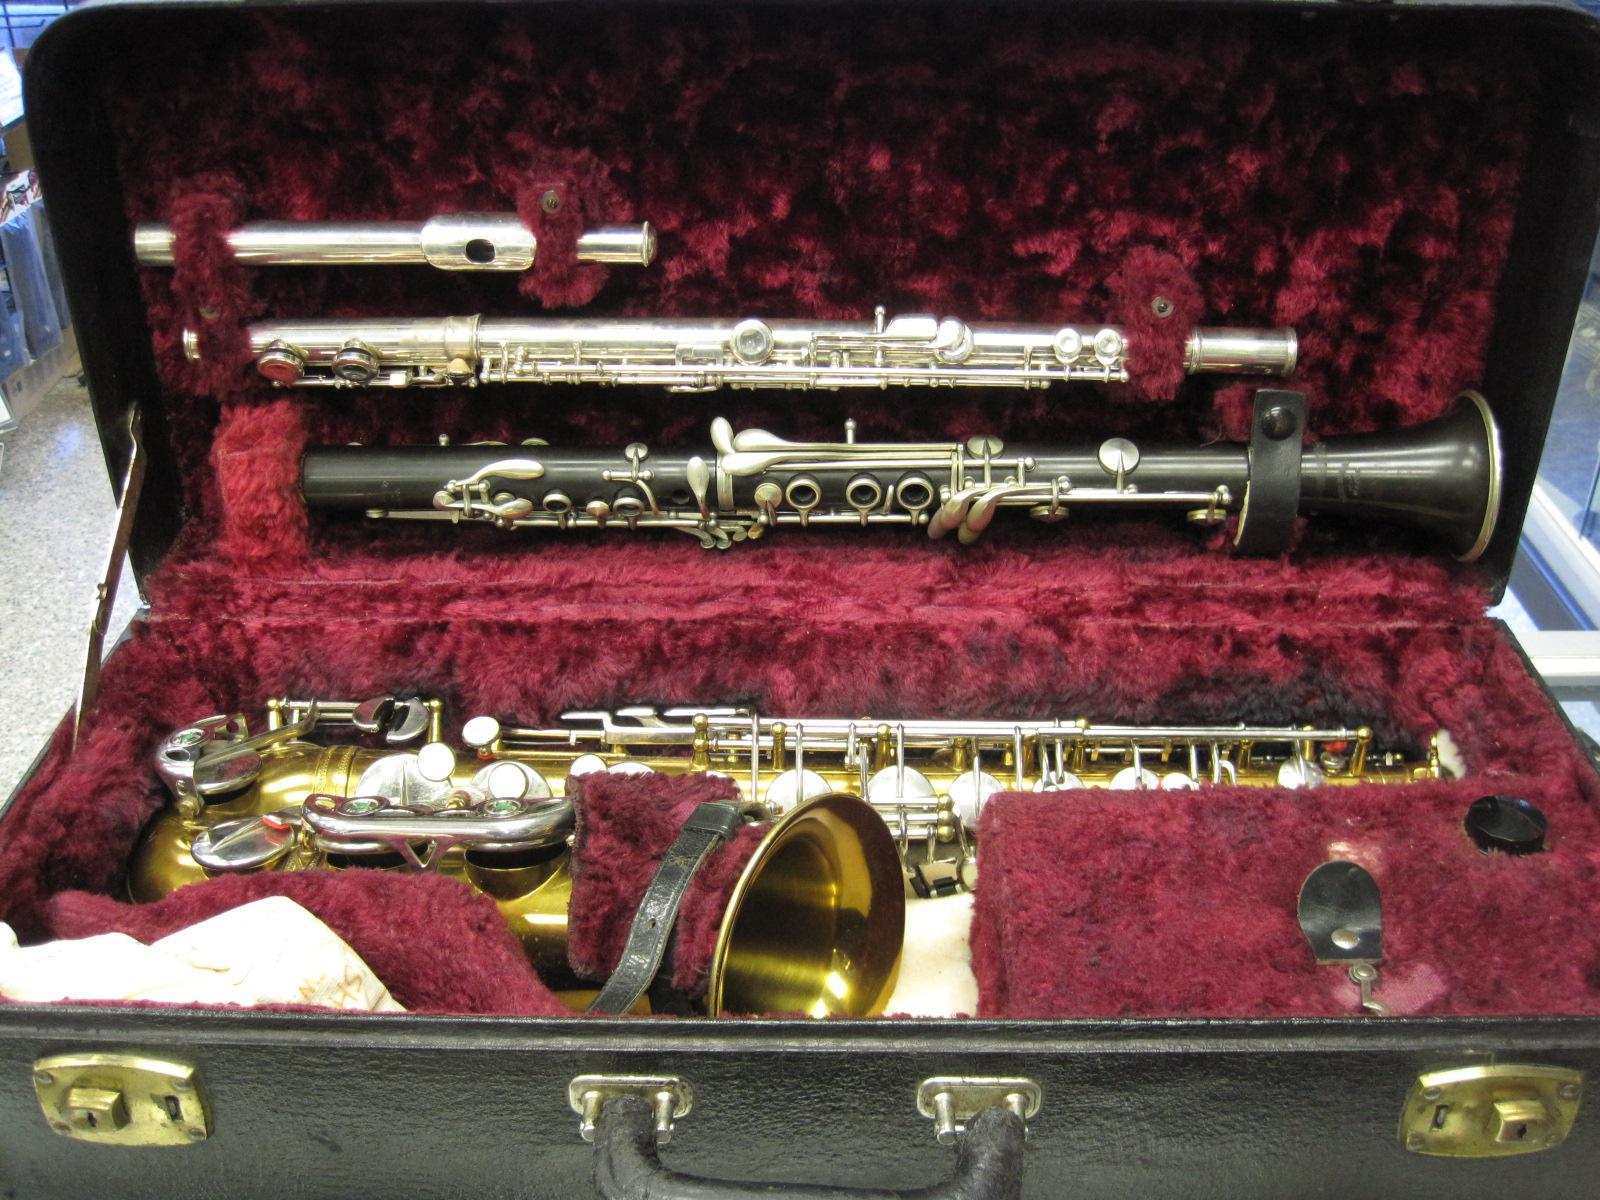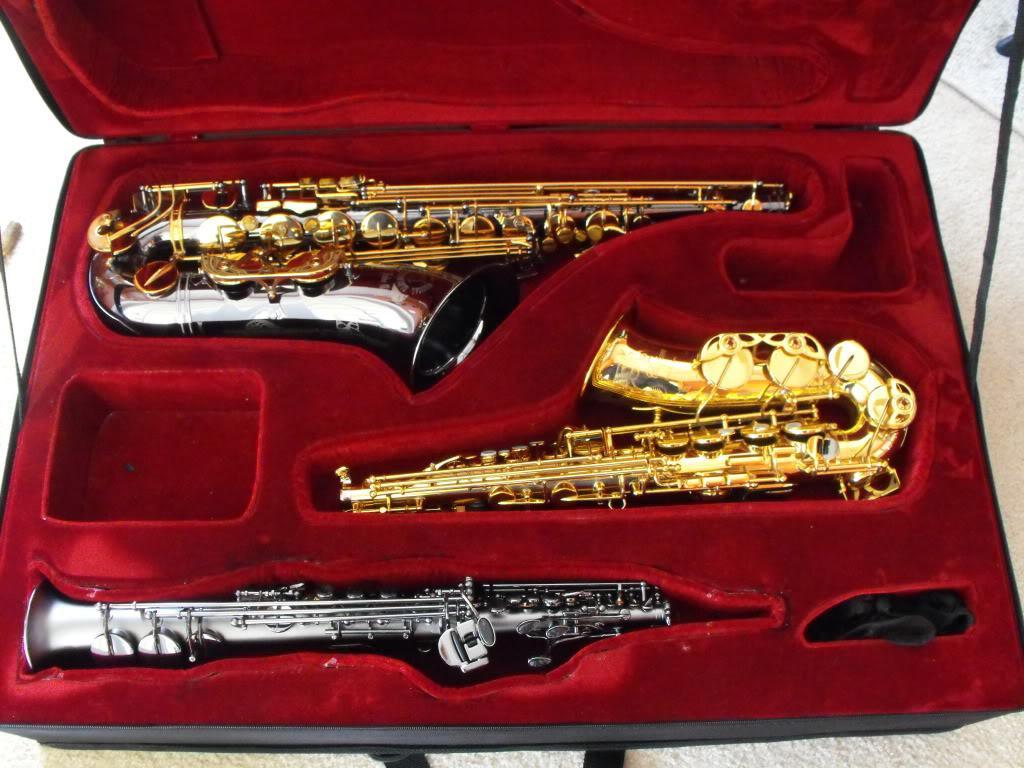The first image is the image on the left, the second image is the image on the right. Considering the images on both sides, is "An image shows a rounded, not rectangular, case, which is lined in black fabric and holds one saxophone." valid? Answer yes or no. No. The first image is the image on the left, the second image is the image on the right. Given the left and right images, does the statement "At least one saxophone case has a burgundy velvet interior." hold true? Answer yes or no. Yes. 